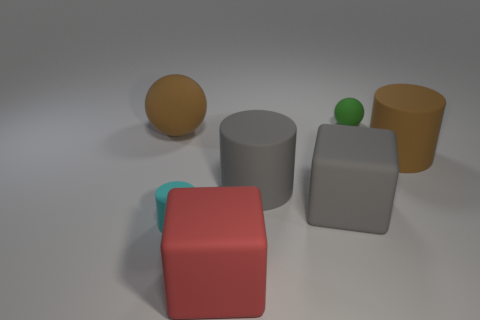Add 2 small gray matte cylinders. How many objects exist? 9 Subtract all cubes. How many objects are left? 5 Subtract all green matte cubes. Subtract all brown rubber spheres. How many objects are left? 6 Add 4 brown matte spheres. How many brown matte spheres are left? 5 Add 2 cyan cylinders. How many cyan cylinders exist? 3 Subtract 0 green blocks. How many objects are left? 7 